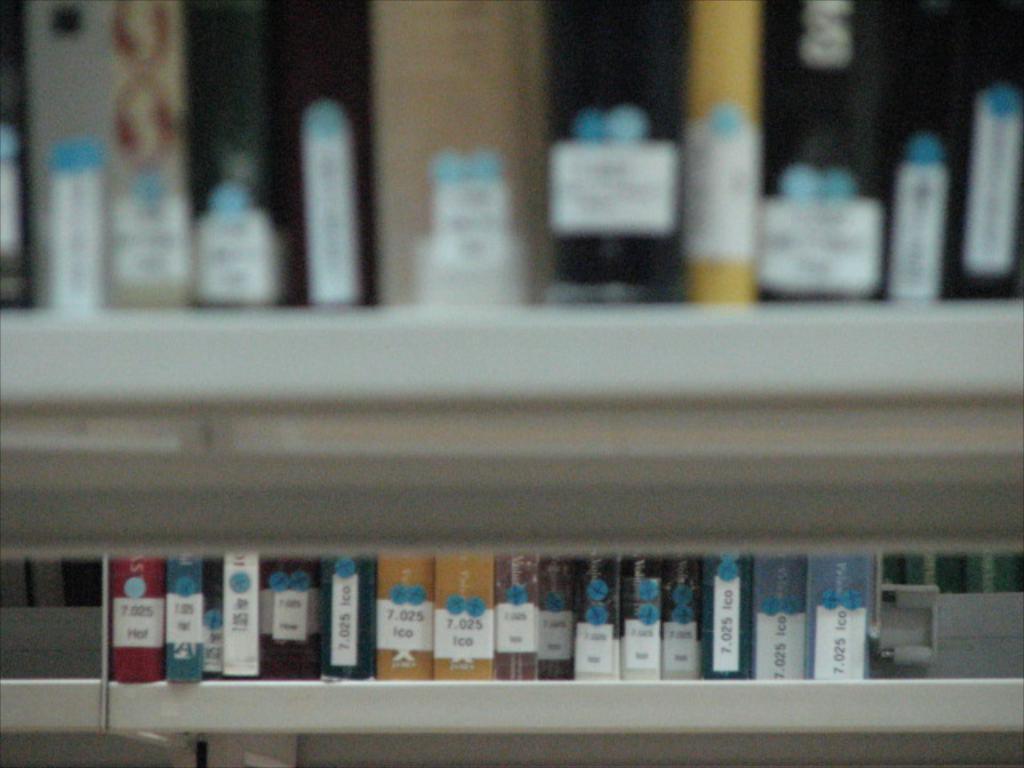Can you describe this image briefly? In this picture I can see many files and books which are kept on this racks. 